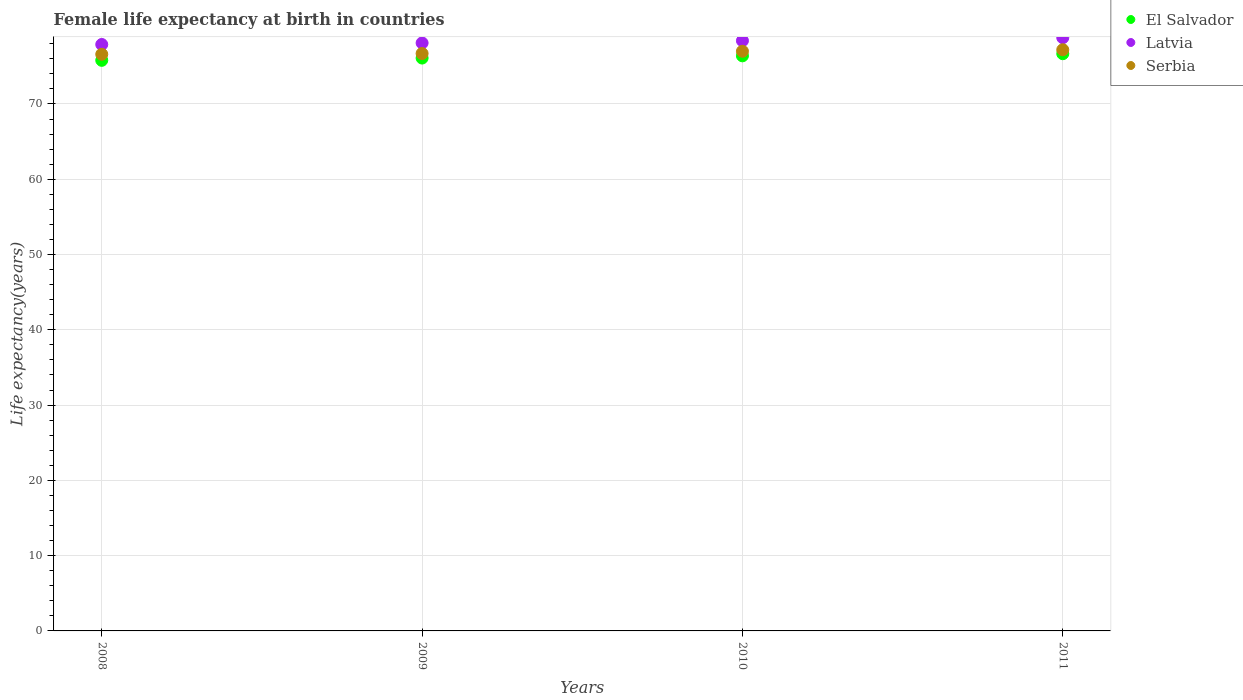What is the female life expectancy at birth in El Salvador in 2010?
Your answer should be very brief. 76.39. Across all years, what is the maximum female life expectancy at birth in El Salvador?
Ensure brevity in your answer.  76.67. Across all years, what is the minimum female life expectancy at birth in Serbia?
Offer a terse response. 76.6. What is the total female life expectancy at birth in El Salvador in the graph?
Give a very brief answer. 304.96. What is the difference between the female life expectancy at birth in Serbia in 2009 and that in 2011?
Keep it short and to the point. -0.5. What is the difference between the female life expectancy at birth in Serbia in 2011 and the female life expectancy at birth in Latvia in 2008?
Ensure brevity in your answer.  -0.7. What is the average female life expectancy at birth in Serbia per year?
Make the answer very short. 76.88. In the year 2010, what is the difference between the female life expectancy at birth in Latvia and female life expectancy at birth in Serbia?
Offer a terse response. 1.4. What is the ratio of the female life expectancy at birth in Serbia in 2010 to that in 2011?
Provide a succinct answer. 1. Is the female life expectancy at birth in El Salvador in 2008 less than that in 2011?
Make the answer very short. Yes. What is the difference between the highest and the second highest female life expectancy at birth in Latvia?
Offer a terse response. 0.4. What is the difference between the highest and the lowest female life expectancy at birth in El Salvador?
Your response must be concise. 0.88. In how many years, is the female life expectancy at birth in Serbia greater than the average female life expectancy at birth in Serbia taken over all years?
Keep it short and to the point. 2. Does the female life expectancy at birth in Serbia monotonically increase over the years?
Your answer should be very brief. Yes. Is the female life expectancy at birth in Latvia strictly less than the female life expectancy at birth in Serbia over the years?
Your response must be concise. No. How many years are there in the graph?
Make the answer very short. 4. Does the graph contain any zero values?
Your answer should be very brief. No. Where does the legend appear in the graph?
Ensure brevity in your answer.  Top right. How are the legend labels stacked?
Your response must be concise. Vertical. What is the title of the graph?
Offer a terse response. Female life expectancy at birth in countries. Does "Ireland" appear as one of the legend labels in the graph?
Keep it short and to the point. No. What is the label or title of the Y-axis?
Keep it short and to the point. Life expectancy(years). What is the Life expectancy(years) in El Salvador in 2008?
Offer a very short reply. 75.79. What is the Life expectancy(years) of Latvia in 2008?
Your response must be concise. 77.9. What is the Life expectancy(years) of Serbia in 2008?
Offer a terse response. 76.6. What is the Life expectancy(years) of El Salvador in 2009?
Ensure brevity in your answer.  76.1. What is the Life expectancy(years) of Latvia in 2009?
Your response must be concise. 78.1. What is the Life expectancy(years) in Serbia in 2009?
Your answer should be compact. 76.7. What is the Life expectancy(years) in El Salvador in 2010?
Provide a short and direct response. 76.39. What is the Life expectancy(years) of Latvia in 2010?
Keep it short and to the point. 78.4. What is the Life expectancy(years) in El Salvador in 2011?
Give a very brief answer. 76.67. What is the Life expectancy(years) of Latvia in 2011?
Provide a succinct answer. 78.8. What is the Life expectancy(years) of Serbia in 2011?
Your answer should be compact. 77.2. Across all years, what is the maximum Life expectancy(years) in El Salvador?
Provide a short and direct response. 76.67. Across all years, what is the maximum Life expectancy(years) of Latvia?
Your response must be concise. 78.8. Across all years, what is the maximum Life expectancy(years) in Serbia?
Your response must be concise. 77.2. Across all years, what is the minimum Life expectancy(years) of El Salvador?
Your response must be concise. 75.79. Across all years, what is the minimum Life expectancy(years) in Latvia?
Your answer should be compact. 77.9. Across all years, what is the minimum Life expectancy(years) in Serbia?
Offer a terse response. 76.6. What is the total Life expectancy(years) of El Salvador in the graph?
Your answer should be very brief. 304.96. What is the total Life expectancy(years) of Latvia in the graph?
Keep it short and to the point. 313.2. What is the total Life expectancy(years) in Serbia in the graph?
Offer a very short reply. 307.5. What is the difference between the Life expectancy(years) in El Salvador in 2008 and that in 2009?
Offer a terse response. -0.3. What is the difference between the Life expectancy(years) of Latvia in 2008 and that in 2009?
Keep it short and to the point. -0.2. What is the difference between the Life expectancy(years) in El Salvador in 2008 and that in 2010?
Your response must be concise. -0.6. What is the difference between the Life expectancy(years) of Latvia in 2008 and that in 2010?
Provide a succinct answer. -0.5. What is the difference between the Life expectancy(years) of Serbia in 2008 and that in 2010?
Ensure brevity in your answer.  -0.4. What is the difference between the Life expectancy(years) in El Salvador in 2008 and that in 2011?
Offer a very short reply. -0.88. What is the difference between the Life expectancy(years) in Latvia in 2008 and that in 2011?
Your answer should be very brief. -0.9. What is the difference between the Life expectancy(years) of El Salvador in 2009 and that in 2010?
Your answer should be compact. -0.29. What is the difference between the Life expectancy(years) of El Salvador in 2009 and that in 2011?
Give a very brief answer. -0.58. What is the difference between the Life expectancy(years) of Latvia in 2009 and that in 2011?
Offer a terse response. -0.7. What is the difference between the Life expectancy(years) in El Salvador in 2010 and that in 2011?
Ensure brevity in your answer.  -0.28. What is the difference between the Life expectancy(years) of Latvia in 2010 and that in 2011?
Ensure brevity in your answer.  -0.4. What is the difference between the Life expectancy(years) in El Salvador in 2008 and the Life expectancy(years) in Latvia in 2009?
Keep it short and to the point. -2.31. What is the difference between the Life expectancy(years) of El Salvador in 2008 and the Life expectancy(years) of Serbia in 2009?
Provide a short and direct response. -0.91. What is the difference between the Life expectancy(years) of Latvia in 2008 and the Life expectancy(years) of Serbia in 2009?
Your answer should be very brief. 1.2. What is the difference between the Life expectancy(years) in El Salvador in 2008 and the Life expectancy(years) in Latvia in 2010?
Make the answer very short. -2.61. What is the difference between the Life expectancy(years) in El Salvador in 2008 and the Life expectancy(years) in Serbia in 2010?
Your response must be concise. -1.21. What is the difference between the Life expectancy(years) in El Salvador in 2008 and the Life expectancy(years) in Latvia in 2011?
Offer a very short reply. -3.01. What is the difference between the Life expectancy(years) in El Salvador in 2008 and the Life expectancy(years) in Serbia in 2011?
Your response must be concise. -1.41. What is the difference between the Life expectancy(years) in Latvia in 2008 and the Life expectancy(years) in Serbia in 2011?
Offer a terse response. 0.7. What is the difference between the Life expectancy(years) of El Salvador in 2009 and the Life expectancy(years) of Latvia in 2010?
Keep it short and to the point. -2.3. What is the difference between the Life expectancy(years) in El Salvador in 2009 and the Life expectancy(years) in Serbia in 2010?
Your answer should be very brief. -0.9. What is the difference between the Life expectancy(years) of El Salvador in 2009 and the Life expectancy(years) of Latvia in 2011?
Keep it short and to the point. -2.7. What is the difference between the Life expectancy(years) of El Salvador in 2009 and the Life expectancy(years) of Serbia in 2011?
Provide a succinct answer. -1.1. What is the difference between the Life expectancy(years) in El Salvador in 2010 and the Life expectancy(years) in Latvia in 2011?
Give a very brief answer. -2.41. What is the difference between the Life expectancy(years) of El Salvador in 2010 and the Life expectancy(years) of Serbia in 2011?
Your answer should be very brief. -0.81. What is the difference between the Life expectancy(years) in Latvia in 2010 and the Life expectancy(years) in Serbia in 2011?
Provide a short and direct response. 1.2. What is the average Life expectancy(years) of El Salvador per year?
Provide a succinct answer. 76.24. What is the average Life expectancy(years) of Latvia per year?
Ensure brevity in your answer.  78.3. What is the average Life expectancy(years) of Serbia per year?
Ensure brevity in your answer.  76.88. In the year 2008, what is the difference between the Life expectancy(years) of El Salvador and Life expectancy(years) of Latvia?
Provide a short and direct response. -2.11. In the year 2008, what is the difference between the Life expectancy(years) of El Salvador and Life expectancy(years) of Serbia?
Your response must be concise. -0.81. In the year 2009, what is the difference between the Life expectancy(years) of El Salvador and Life expectancy(years) of Latvia?
Your answer should be very brief. -2. In the year 2009, what is the difference between the Life expectancy(years) of El Salvador and Life expectancy(years) of Serbia?
Your answer should be compact. -0.6. In the year 2010, what is the difference between the Life expectancy(years) of El Salvador and Life expectancy(years) of Latvia?
Provide a succinct answer. -2.01. In the year 2010, what is the difference between the Life expectancy(years) of El Salvador and Life expectancy(years) of Serbia?
Your answer should be very brief. -0.61. In the year 2011, what is the difference between the Life expectancy(years) in El Salvador and Life expectancy(years) in Latvia?
Keep it short and to the point. -2.13. In the year 2011, what is the difference between the Life expectancy(years) of El Salvador and Life expectancy(years) of Serbia?
Your answer should be compact. -0.53. In the year 2011, what is the difference between the Life expectancy(years) of Latvia and Life expectancy(years) of Serbia?
Your response must be concise. 1.6. What is the ratio of the Life expectancy(years) in Latvia in 2008 to that in 2009?
Make the answer very short. 1. What is the ratio of the Life expectancy(years) in El Salvador in 2008 to that in 2010?
Offer a very short reply. 0.99. What is the ratio of the Life expectancy(years) of Latvia in 2008 to that in 2010?
Keep it short and to the point. 0.99. What is the ratio of the Life expectancy(years) of Serbia in 2008 to that in 2010?
Make the answer very short. 0.99. What is the ratio of the Life expectancy(years) in El Salvador in 2008 to that in 2011?
Your answer should be compact. 0.99. What is the ratio of the Life expectancy(years) in Latvia in 2008 to that in 2011?
Provide a succinct answer. 0.99. What is the ratio of the Life expectancy(years) of El Salvador in 2009 to that in 2010?
Your answer should be very brief. 1. What is the ratio of the Life expectancy(years) in El Salvador in 2009 to that in 2011?
Your answer should be very brief. 0.99. What is the ratio of the Life expectancy(years) of Latvia in 2010 to that in 2011?
Keep it short and to the point. 0.99. What is the ratio of the Life expectancy(years) of Serbia in 2010 to that in 2011?
Your answer should be compact. 1. What is the difference between the highest and the second highest Life expectancy(years) of El Salvador?
Your answer should be very brief. 0.28. What is the difference between the highest and the second highest Life expectancy(years) of Serbia?
Your answer should be compact. 0.2. What is the difference between the highest and the lowest Life expectancy(years) of Latvia?
Offer a very short reply. 0.9. What is the difference between the highest and the lowest Life expectancy(years) in Serbia?
Your answer should be very brief. 0.6. 